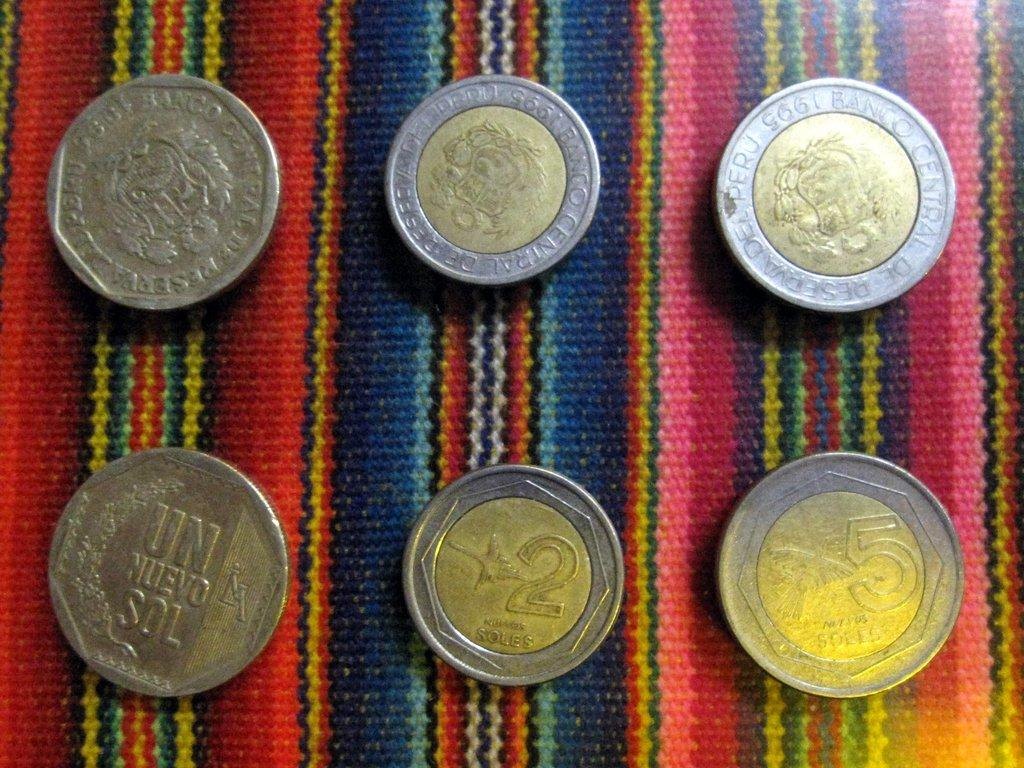<image>
Give a short and clear explanation of the subsequent image. six coins of various denominations like 5 Soles on a colorful cloth 